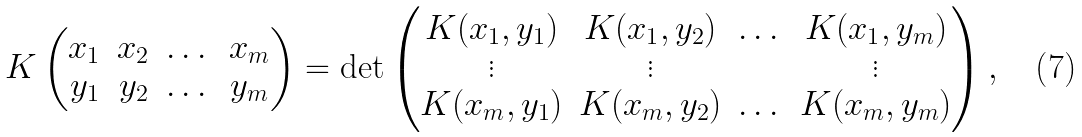Convert formula to latex. <formula><loc_0><loc_0><loc_500><loc_500>K \begin{pmatrix} x _ { 1 } & x _ { 2 } & \dots & x _ { m } \\ y _ { 1 } & y _ { 2 } & \dots & y _ { m } \end{pmatrix} = \det \begin{pmatrix} K ( x _ { 1 } , y _ { 1 } ) & K ( x _ { 1 } , y _ { 2 } ) & \dots & K ( x _ { 1 } , y _ { m } ) \\ \vdots & \vdots & & \vdots \\ K ( x _ { m } , y _ { 1 } ) & K ( x _ { m } , y _ { 2 } ) & \dots & K ( x _ { m } , y _ { m } ) \end{pmatrix} ,</formula> 